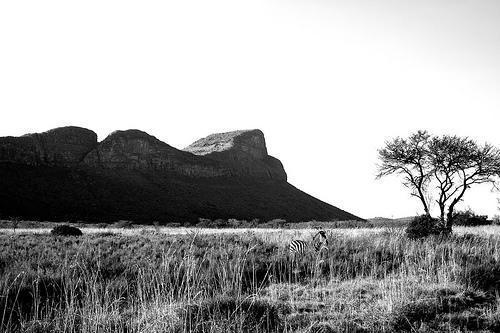How many trees are visible?
Give a very brief answer. 3. 